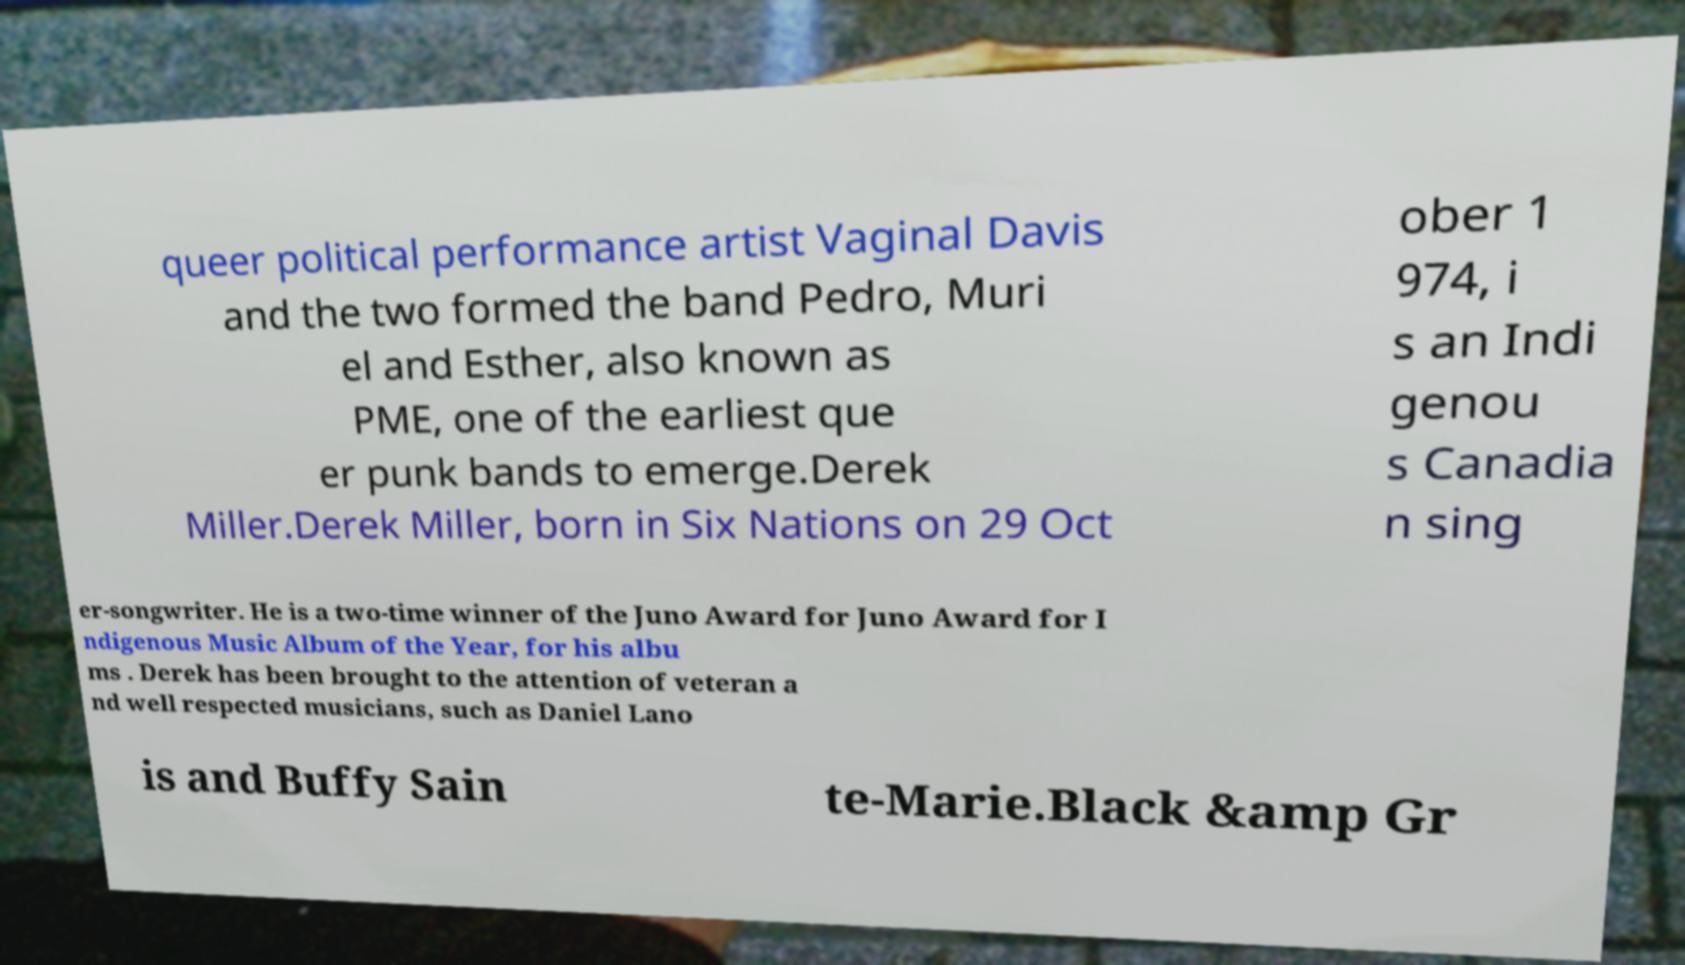I need the written content from this picture converted into text. Can you do that? queer political performance artist Vaginal Davis and the two formed the band Pedro, Muri el and Esther, also known as PME, one of the earliest que er punk bands to emerge.Derek Miller.Derek Miller, born in Six Nations on 29 Oct ober 1 974, i s an Indi genou s Canadia n sing er-songwriter. He is a two-time winner of the Juno Award for Juno Award for I ndigenous Music Album of the Year, for his albu ms . Derek has been brought to the attention of veteran a nd well respected musicians, such as Daniel Lano is and Buffy Sain te-Marie.Black &amp Gr 